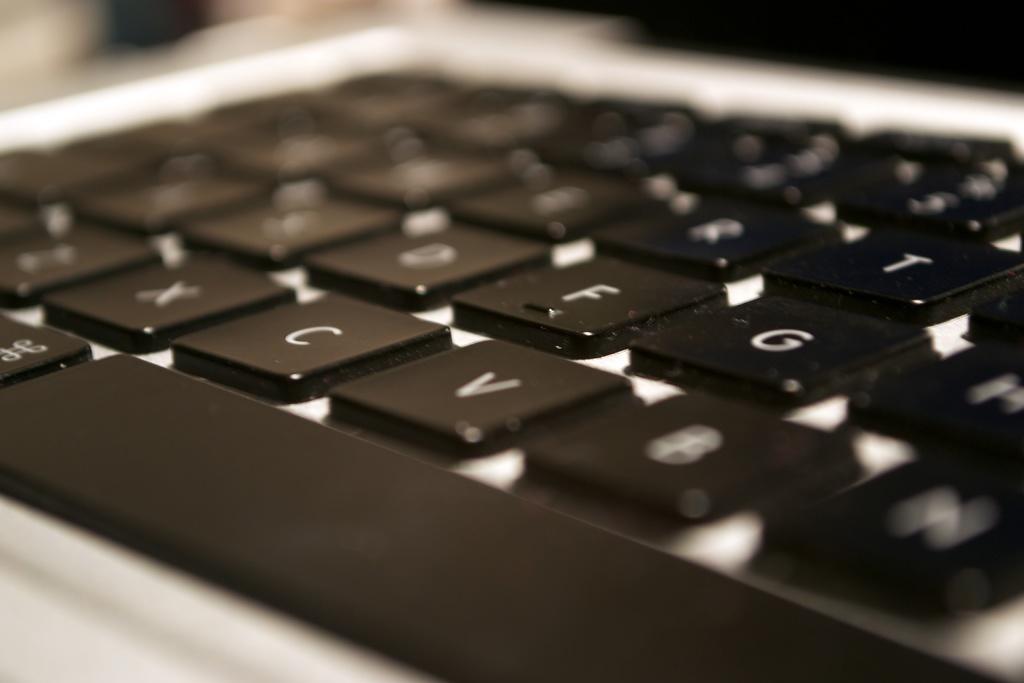Which key is located to the left of v?
Provide a short and direct response. C. What is the key after c?
Your answer should be compact. V. 